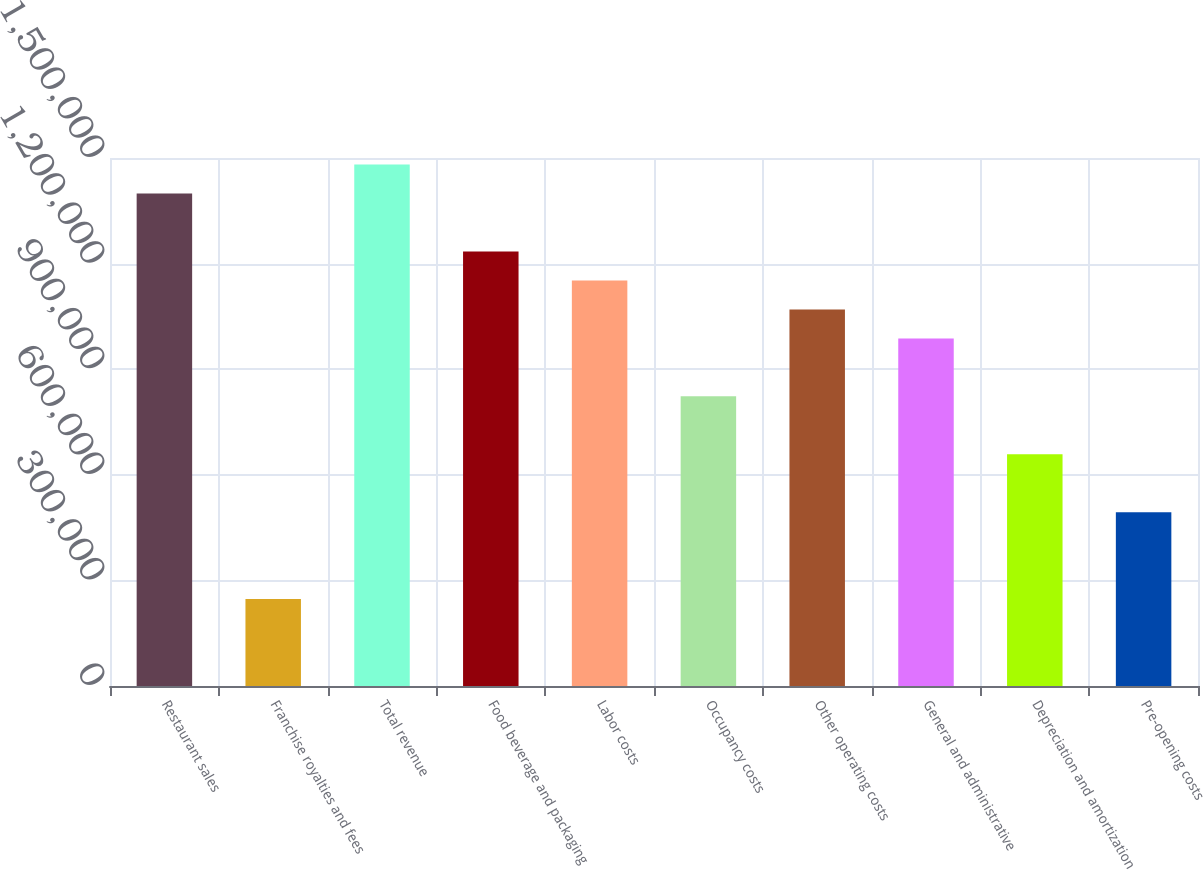Convert chart. <chart><loc_0><loc_0><loc_500><loc_500><bar_chart><fcel>Restaurant sales<fcel>Franchise royalties and fees<fcel>Total revenue<fcel>Food beverage and packaging<fcel>Labor costs<fcel>Occupancy costs<fcel>Other operating costs<fcel>General and administrative<fcel>Depreciation and amortization<fcel>Pre-opening costs<nl><fcel>1.39898e+06<fcel>246880<fcel>1.48127e+06<fcel>1.23439e+06<fcel>1.1521e+06<fcel>822930<fcel>1.06981e+06<fcel>987516<fcel>658344<fcel>493758<nl></chart> 